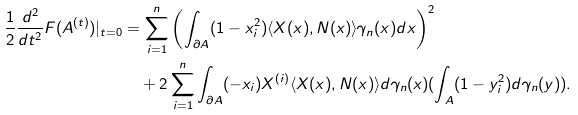Convert formula to latex. <formula><loc_0><loc_0><loc_500><loc_500>\frac { 1 } { 2 } \frac { d ^ { 2 } } { d t ^ { 2 } } F ( A ^ { ( t ) } ) | _ { t = 0 } & = \sum _ { i = 1 } ^ { n } \left ( \int _ { \partial A } ( 1 - x _ { i } ^ { 2 } ) \langle X ( x ) , N ( x ) \rangle \gamma _ { n } ( x ) d x \right ) ^ { 2 } \\ & \quad + 2 \sum _ { i = 1 } ^ { n } \int _ { \partial A } ( - x _ { i } ) X ^ { ( i ) } \langle X ( x ) , N ( x ) \rangle d \gamma _ { n } ( x ) ( \int _ { A } ( 1 - y _ { i } ^ { 2 } ) d \gamma _ { n } ( y ) ) .</formula> 